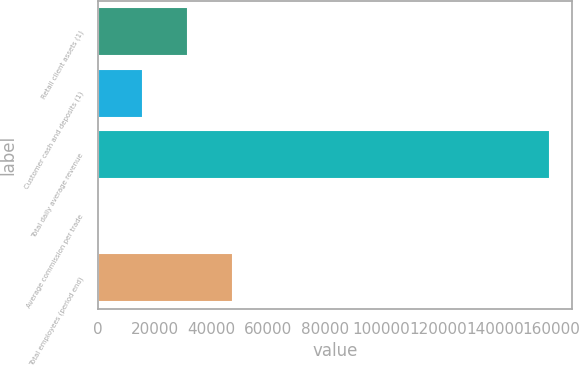Convert chart. <chart><loc_0><loc_0><loc_500><loc_500><bar_chart><fcel>Retail client assets (1)<fcel>Customer cash and deposits (1)<fcel>Total daily average revenue<fcel>Average commission per trade<fcel>Total employees (period end)<nl><fcel>31879.2<fcel>15945.6<fcel>159348<fcel>12.05<fcel>47812.8<nl></chart> 